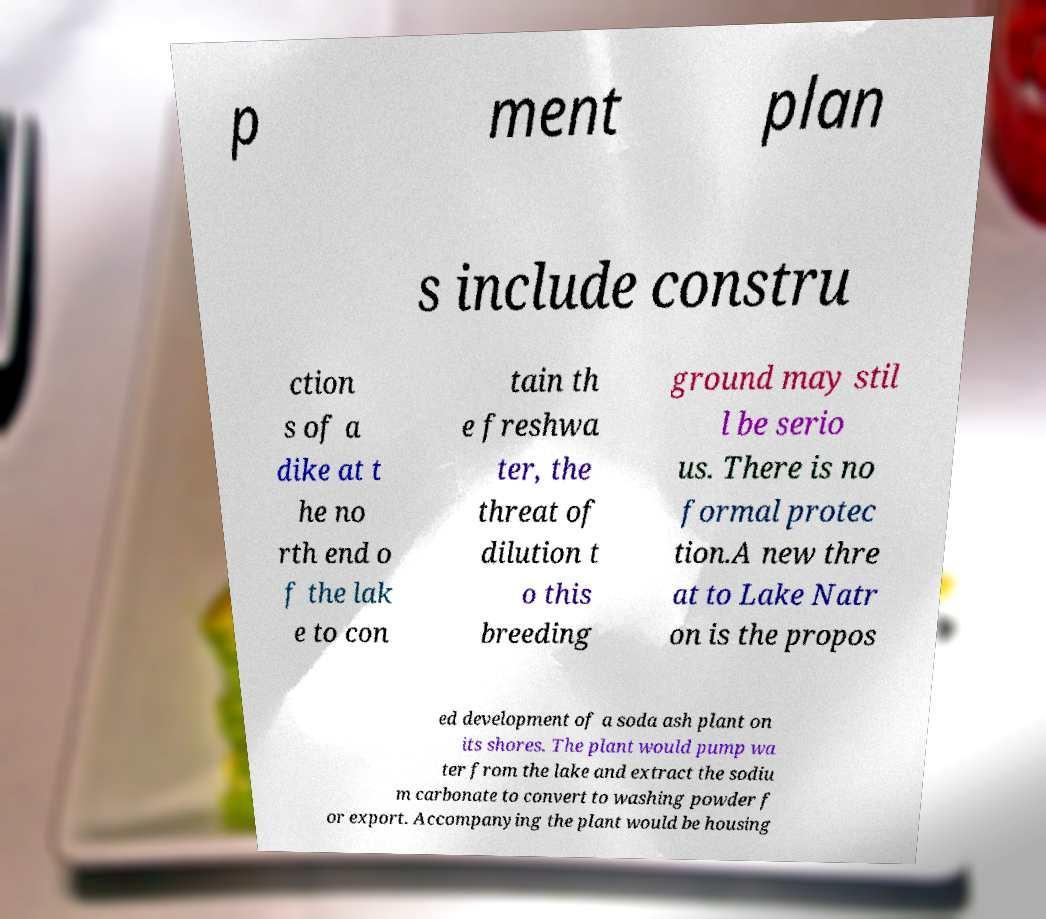For documentation purposes, I need the text within this image transcribed. Could you provide that? p ment plan s include constru ction s of a dike at t he no rth end o f the lak e to con tain th e freshwa ter, the threat of dilution t o this breeding ground may stil l be serio us. There is no formal protec tion.A new thre at to Lake Natr on is the propos ed development of a soda ash plant on its shores. The plant would pump wa ter from the lake and extract the sodiu m carbonate to convert to washing powder f or export. Accompanying the plant would be housing 